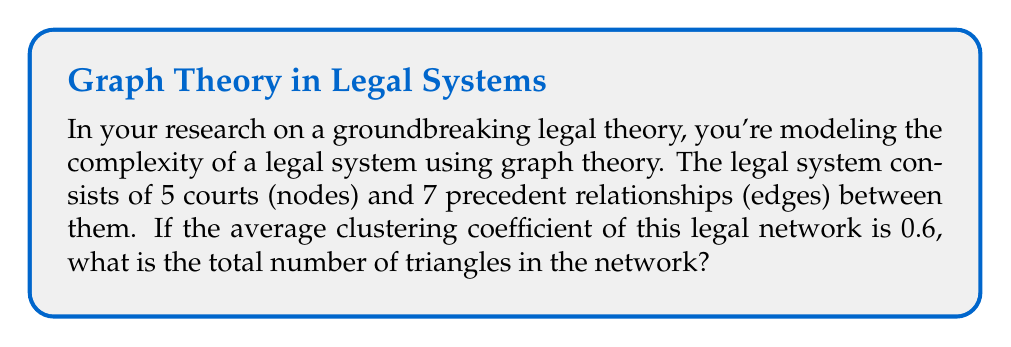Solve this math problem. Let's approach this step-by-step:

1) In graph theory, the clustering coefficient measures the degree to which nodes in a graph tend to cluster together. For an undirected graph, the local clustering coefficient for a vertex $v$ is given by:

   $$C_v = \frac{2T(v)}{k_v(k_v-1)}$$

   where $T(v)$ is the number of triangles through the vertex $v$ and $k_v$ is the degree of $v$.

2) The average clustering coefficient is the mean of the local clustering coefficients of all vertices:

   $$C = \frac{1}{n}\sum_{v \in V} C_v$$

   where $n$ is the number of vertices.

3) We're given that the average clustering coefficient is 0.6 and there are 5 nodes. So:

   $$0.6 = \frac{1}{5}\sum_{v \in V} C_v$$

4) Multiply both sides by 5:

   $$3 = \sum_{v \in V} C_v = \sum_{v \in V} \frac{2T(v)}{k_v(k_v-1)}$$

5) The sum of $T(v)$ over all vertices is equal to three times the total number of triangles in the graph (as each triangle is counted once for each of its three vertices). Let's call the total number of triangles $T$. Then:

   $$3 = \sum_{v \in V} \frac{2(3T)}{k_v(k_v-1)}$$

6) Simplify:

   $$1 = \sum_{v \in V} \frac{2T}{k_v(k_v-1)}$$

7) The denominator $\sum_{v \in V} \frac{1}{k_v(k_v-1)}$ is a constant for this graph. Let's call it $K$. Then:

   $$1 = 2TK$$
   $$T = \frac{1}{2K}$$

8) We don't know $K$, but we know it must be a value that makes $T$ an integer. The smallest possible value for $K$ that achieves this is $\frac{1}{2}$, which gives $T = 1$.

Therefore, the total number of triangles in the network is 1.
Answer: 1 